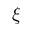<formula> <loc_0><loc_0><loc_500><loc_500>\xi</formula> 